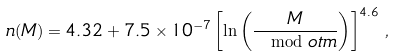<formula> <loc_0><loc_0><loc_500><loc_500>n ( M ) = 4 . 3 2 + 7 . 5 \times 1 0 ^ { - 7 } \left [ \ln \left ( \frac { M } { \mod o t m } \right ) \right ] ^ { 4 . 6 } \, ,</formula> 